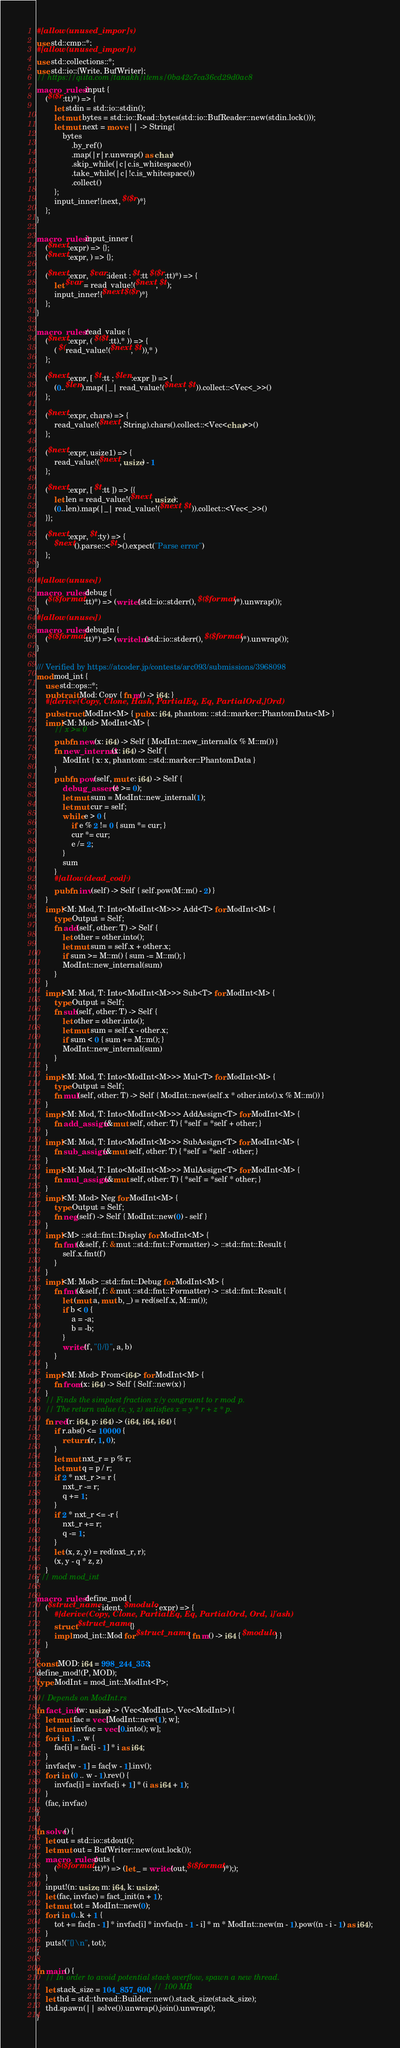<code> <loc_0><loc_0><loc_500><loc_500><_Rust_>#[allow(unused_imports)]
use std::cmp::*;
#[allow(unused_imports)]
use std::collections::*;
use std::io::{Write, BufWriter};
// https://qiita.com/tanakh/items/0ba42c7ca36cd29d0ac8
macro_rules! input {
    ($($r:tt)*) => {
        let stdin = std::io::stdin();
        let mut bytes = std::io::Read::bytes(std::io::BufReader::new(stdin.lock()));
        let mut next = move || -> String{
            bytes
                .by_ref()
                .map(|r|r.unwrap() as char)
                .skip_while(|c|c.is_whitespace())
                .take_while(|c|!c.is_whitespace())
                .collect()
        };
        input_inner!{next, $($r)*}
    };
}

macro_rules! input_inner {
    ($next:expr) => {};
    ($next:expr, ) => {};

    ($next:expr, $var:ident : $t:tt $($r:tt)*) => {
        let $var = read_value!($next, $t);
        input_inner!{$next $($r)*}
    };
}

macro_rules! read_value {
    ($next:expr, ( $($t:tt),* )) => {
        ( $(read_value!($next, $t)),* )
    };

    ($next:expr, [ $t:tt ; $len:expr ]) => {
        (0..$len).map(|_| read_value!($next, $t)).collect::<Vec<_>>()
    };

    ($next:expr, chars) => {
        read_value!($next, String).chars().collect::<Vec<char>>()
    };

    ($next:expr, usize1) => {
        read_value!($next, usize) - 1
    };

    ($next:expr, [ $t:tt ]) => {{
        let len = read_value!($next, usize);
        (0..len).map(|_| read_value!($next, $t)).collect::<Vec<_>>()
    }};

    ($next:expr, $t:ty) => {
        $next().parse::<$t>().expect("Parse error")
    };
}

#[allow(unused)]
macro_rules! debug {
    ($($format:tt)*) => (write!(std::io::stderr(), $($format)*).unwrap());
}
#[allow(unused)]
macro_rules! debugln {
    ($($format:tt)*) => (writeln!(std::io::stderr(), $($format)*).unwrap());
}

/// Verified by https://atcoder.jp/contests/arc093/submissions/3968098
mod mod_int {
    use std::ops::*;
    pub trait Mod: Copy { fn m() -> i64; }
    #[derive(Copy, Clone, Hash, PartialEq, Eq, PartialOrd, Ord)]
    pub struct ModInt<M> { pub x: i64, phantom: ::std::marker::PhantomData<M> }
    impl<M: Mod> ModInt<M> {
        // x >= 0
        pub fn new(x: i64) -> Self { ModInt::new_internal(x % M::m()) }
        fn new_internal(x: i64) -> Self {
            ModInt { x: x, phantom: ::std::marker::PhantomData }
        }
        pub fn pow(self, mut e: i64) -> Self {
            debug_assert!(e >= 0);
            let mut sum = ModInt::new_internal(1);
            let mut cur = self;
            while e > 0 {
                if e % 2 != 0 { sum *= cur; }
                cur *= cur;
                e /= 2;
            }
            sum
        }
        #[allow(dead_code)]
        pub fn inv(self) -> Self { self.pow(M::m() - 2) }
    }
    impl<M: Mod, T: Into<ModInt<M>>> Add<T> for ModInt<M> {
        type Output = Self;
        fn add(self, other: T) -> Self {
            let other = other.into();
            let mut sum = self.x + other.x;
            if sum >= M::m() { sum -= M::m(); }
            ModInt::new_internal(sum)
        }
    }
    impl<M: Mod, T: Into<ModInt<M>>> Sub<T> for ModInt<M> {
        type Output = Self;
        fn sub(self, other: T) -> Self {
            let other = other.into();
            let mut sum = self.x - other.x;
            if sum < 0 { sum += M::m(); }
            ModInt::new_internal(sum)
        }
    }
    impl<M: Mod, T: Into<ModInt<M>>> Mul<T> for ModInt<M> {
        type Output = Self;
        fn mul(self, other: T) -> Self { ModInt::new(self.x * other.into().x % M::m()) }
    }
    impl<M: Mod, T: Into<ModInt<M>>> AddAssign<T> for ModInt<M> {
        fn add_assign(&mut self, other: T) { *self = *self + other; }
    }
    impl<M: Mod, T: Into<ModInt<M>>> SubAssign<T> for ModInt<M> {
        fn sub_assign(&mut self, other: T) { *self = *self - other; }
    }
    impl<M: Mod, T: Into<ModInt<M>>> MulAssign<T> for ModInt<M> {
        fn mul_assign(&mut self, other: T) { *self = *self * other; }
    }
    impl<M: Mod> Neg for ModInt<M> {
        type Output = Self;
        fn neg(self) -> Self { ModInt::new(0) - self }
    }
    impl<M> ::std::fmt::Display for ModInt<M> {
        fn fmt(&self, f: &mut ::std::fmt::Formatter) -> ::std::fmt::Result {
            self.x.fmt(f)
        }
    }
    impl<M: Mod> ::std::fmt::Debug for ModInt<M> {
        fn fmt(&self, f: &mut ::std::fmt::Formatter) -> ::std::fmt::Result {
            let (mut a, mut b, _) = red(self.x, M::m());
            if b < 0 {
                a = -a;
                b = -b;
            }
            write!(f, "{}/{}", a, b)
        }
    }
    impl<M: Mod> From<i64> for ModInt<M> {
        fn from(x: i64) -> Self { Self::new(x) }
    }
    // Finds the simplest fraction x/y congruent to r mod p.
    // The return value (x, y, z) satisfies x = y * r + z * p.
    fn red(r: i64, p: i64) -> (i64, i64, i64) {
        if r.abs() <= 10000 {
            return (r, 1, 0);
        }
        let mut nxt_r = p % r;
        let mut q = p / r;
        if 2 * nxt_r >= r {
            nxt_r -= r;
            q += 1;
        }
        if 2 * nxt_r <= -r {
            nxt_r += r;
            q -= 1;
        }
        let (x, z, y) = red(nxt_r, r);
        (x, y - q * z, z)
    }
} // mod mod_int

macro_rules! define_mod {
    ($struct_name: ident, $modulo: expr) => {
        #[derive(Copy, Clone, PartialEq, Eq, PartialOrd, Ord, Hash)]
        struct $struct_name {}
        impl mod_int::Mod for $struct_name { fn m() -> i64 { $modulo } }
    }
}
const MOD: i64 = 998_244_353;
define_mod!(P, MOD);
type ModInt = mod_int::ModInt<P>;

// Depends on ModInt.rs
fn fact_init(w: usize) -> (Vec<ModInt>, Vec<ModInt>) {
    let mut fac = vec![ModInt::new(1); w];
    let mut invfac = vec![0.into(); w];
    for i in 1 .. w {
        fac[i] = fac[i - 1] * i as i64;
    }
    invfac[w - 1] = fac[w - 1].inv();
    for i in (0 .. w - 1).rev() {
        invfac[i] = invfac[i + 1] * (i as i64 + 1);
    }
    (fac, invfac)
}

fn solve() {
    let out = std::io::stdout();
    let mut out = BufWriter::new(out.lock());
    macro_rules! puts {
        ($($format:tt)*) => (let _ = write!(out,$($format)*););
    }
    input!(n: usize, m: i64, k: usize);
    let (fac, invfac) = fact_init(n + 1);
    let mut tot = ModInt::new(0);
    for i in 0..k + 1 {
        tot += fac[n - 1] * invfac[i] * invfac[n - 1 - i] * m * ModInt::new(m - 1).pow((n - i - 1) as i64);
    }
    puts!("{}\n", tot);
}

fn main() {
    // In order to avoid potential stack overflow, spawn a new thread.
    let stack_size = 104_857_600; // 100 MB
    let thd = std::thread::Builder::new().stack_size(stack_size);
    thd.spawn(|| solve()).unwrap().join().unwrap();
}
</code> 